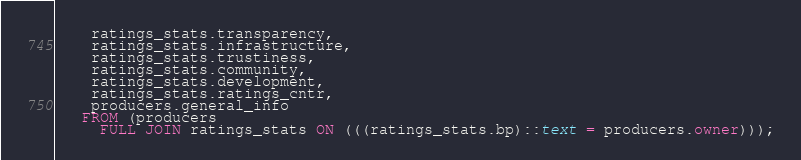<code> <loc_0><loc_0><loc_500><loc_500><_SQL_>    ratings_stats.transparency,
    ratings_stats.infrastructure,
    ratings_stats.trustiness,
    ratings_stats.community,
    ratings_stats.development,
    ratings_stats.ratings_cntr,
    producers.general_info
   FROM (producers
     FULL JOIN ratings_stats ON (((ratings_stats.bp)::text = producers.owner)));</code> 